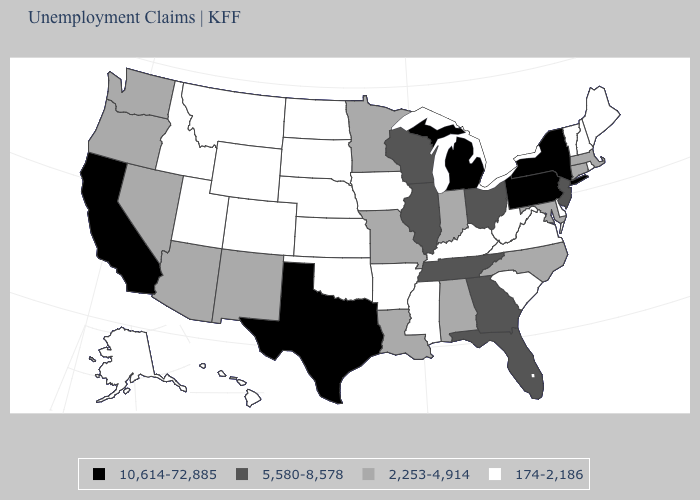What is the value of Maryland?
Give a very brief answer. 2,253-4,914. What is the lowest value in the USA?
Short answer required. 174-2,186. Among the states that border Maine , which have the highest value?
Short answer required. New Hampshire. What is the value of Missouri?
Short answer required. 2,253-4,914. Name the states that have a value in the range 2,253-4,914?
Concise answer only. Alabama, Arizona, Connecticut, Indiana, Louisiana, Maryland, Massachusetts, Minnesota, Missouri, Nevada, New Mexico, North Carolina, Oregon, Washington. Name the states that have a value in the range 2,253-4,914?
Be succinct. Alabama, Arizona, Connecticut, Indiana, Louisiana, Maryland, Massachusetts, Minnesota, Missouri, Nevada, New Mexico, North Carolina, Oregon, Washington. Does Nebraska have the highest value in the MidWest?
Keep it brief. No. What is the value of Georgia?
Keep it brief. 5,580-8,578. What is the lowest value in the West?
Give a very brief answer. 174-2,186. Does the map have missing data?
Write a very short answer. No. Among the states that border Illinois , does Kentucky have the lowest value?
Short answer required. Yes. Does New Hampshire have the lowest value in the USA?
Short answer required. Yes. Name the states that have a value in the range 174-2,186?
Concise answer only. Alaska, Arkansas, Colorado, Delaware, Hawaii, Idaho, Iowa, Kansas, Kentucky, Maine, Mississippi, Montana, Nebraska, New Hampshire, North Dakota, Oklahoma, Rhode Island, South Carolina, South Dakota, Utah, Vermont, Virginia, West Virginia, Wyoming. Which states have the lowest value in the USA?
Quick response, please. Alaska, Arkansas, Colorado, Delaware, Hawaii, Idaho, Iowa, Kansas, Kentucky, Maine, Mississippi, Montana, Nebraska, New Hampshire, North Dakota, Oklahoma, Rhode Island, South Carolina, South Dakota, Utah, Vermont, Virginia, West Virginia, Wyoming. 